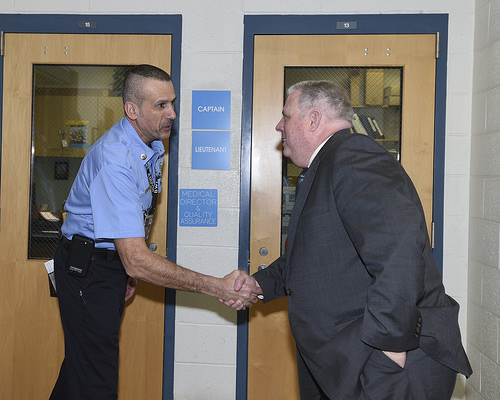<image>
Is the man in front of the man? Yes. The man is positioned in front of the man, appearing closer to the camera viewpoint. Is the frame above the wall? No. The frame is not positioned above the wall. The vertical arrangement shows a different relationship. 